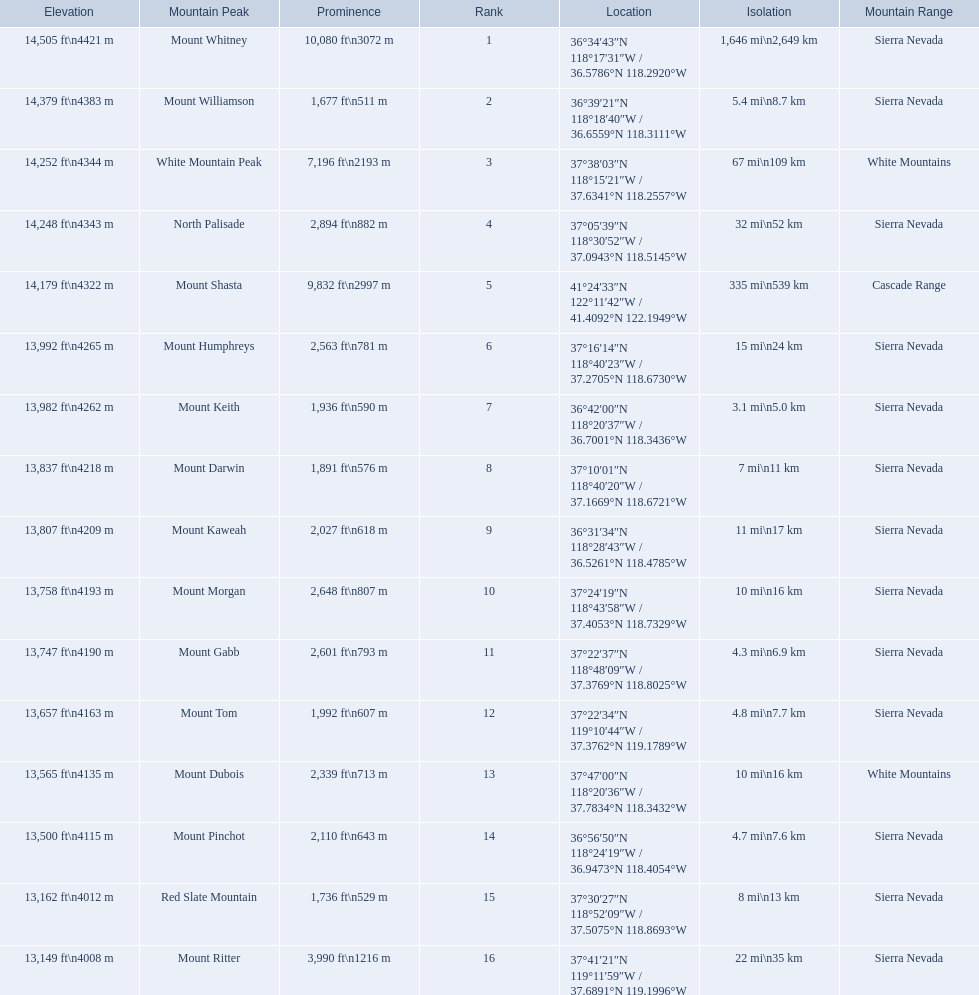What are the peaks in california? Mount Whitney, Mount Williamson, White Mountain Peak, North Palisade, Mount Shasta, Mount Humphreys, Mount Keith, Mount Darwin, Mount Kaweah, Mount Morgan, Mount Gabb, Mount Tom, Mount Dubois, Mount Pinchot, Red Slate Mountain, Mount Ritter. What are the peaks in sierra nevada, california? Mount Whitney, Mount Williamson, North Palisade, Mount Humphreys, Mount Keith, Mount Darwin, Mount Kaweah, Mount Morgan, Mount Gabb, Mount Tom, Mount Pinchot, Red Slate Mountain, Mount Ritter. What are the heights of the peaks in sierra nevada? 14,505 ft\n4421 m, 14,379 ft\n4383 m, 14,248 ft\n4343 m, 13,992 ft\n4265 m, 13,982 ft\n4262 m, 13,837 ft\n4218 m, 13,807 ft\n4209 m, 13,758 ft\n4193 m, 13,747 ft\n4190 m, 13,657 ft\n4163 m, 13,500 ft\n4115 m, 13,162 ft\n4012 m, 13,149 ft\n4008 m. Which is the highest? Mount Whitney. 